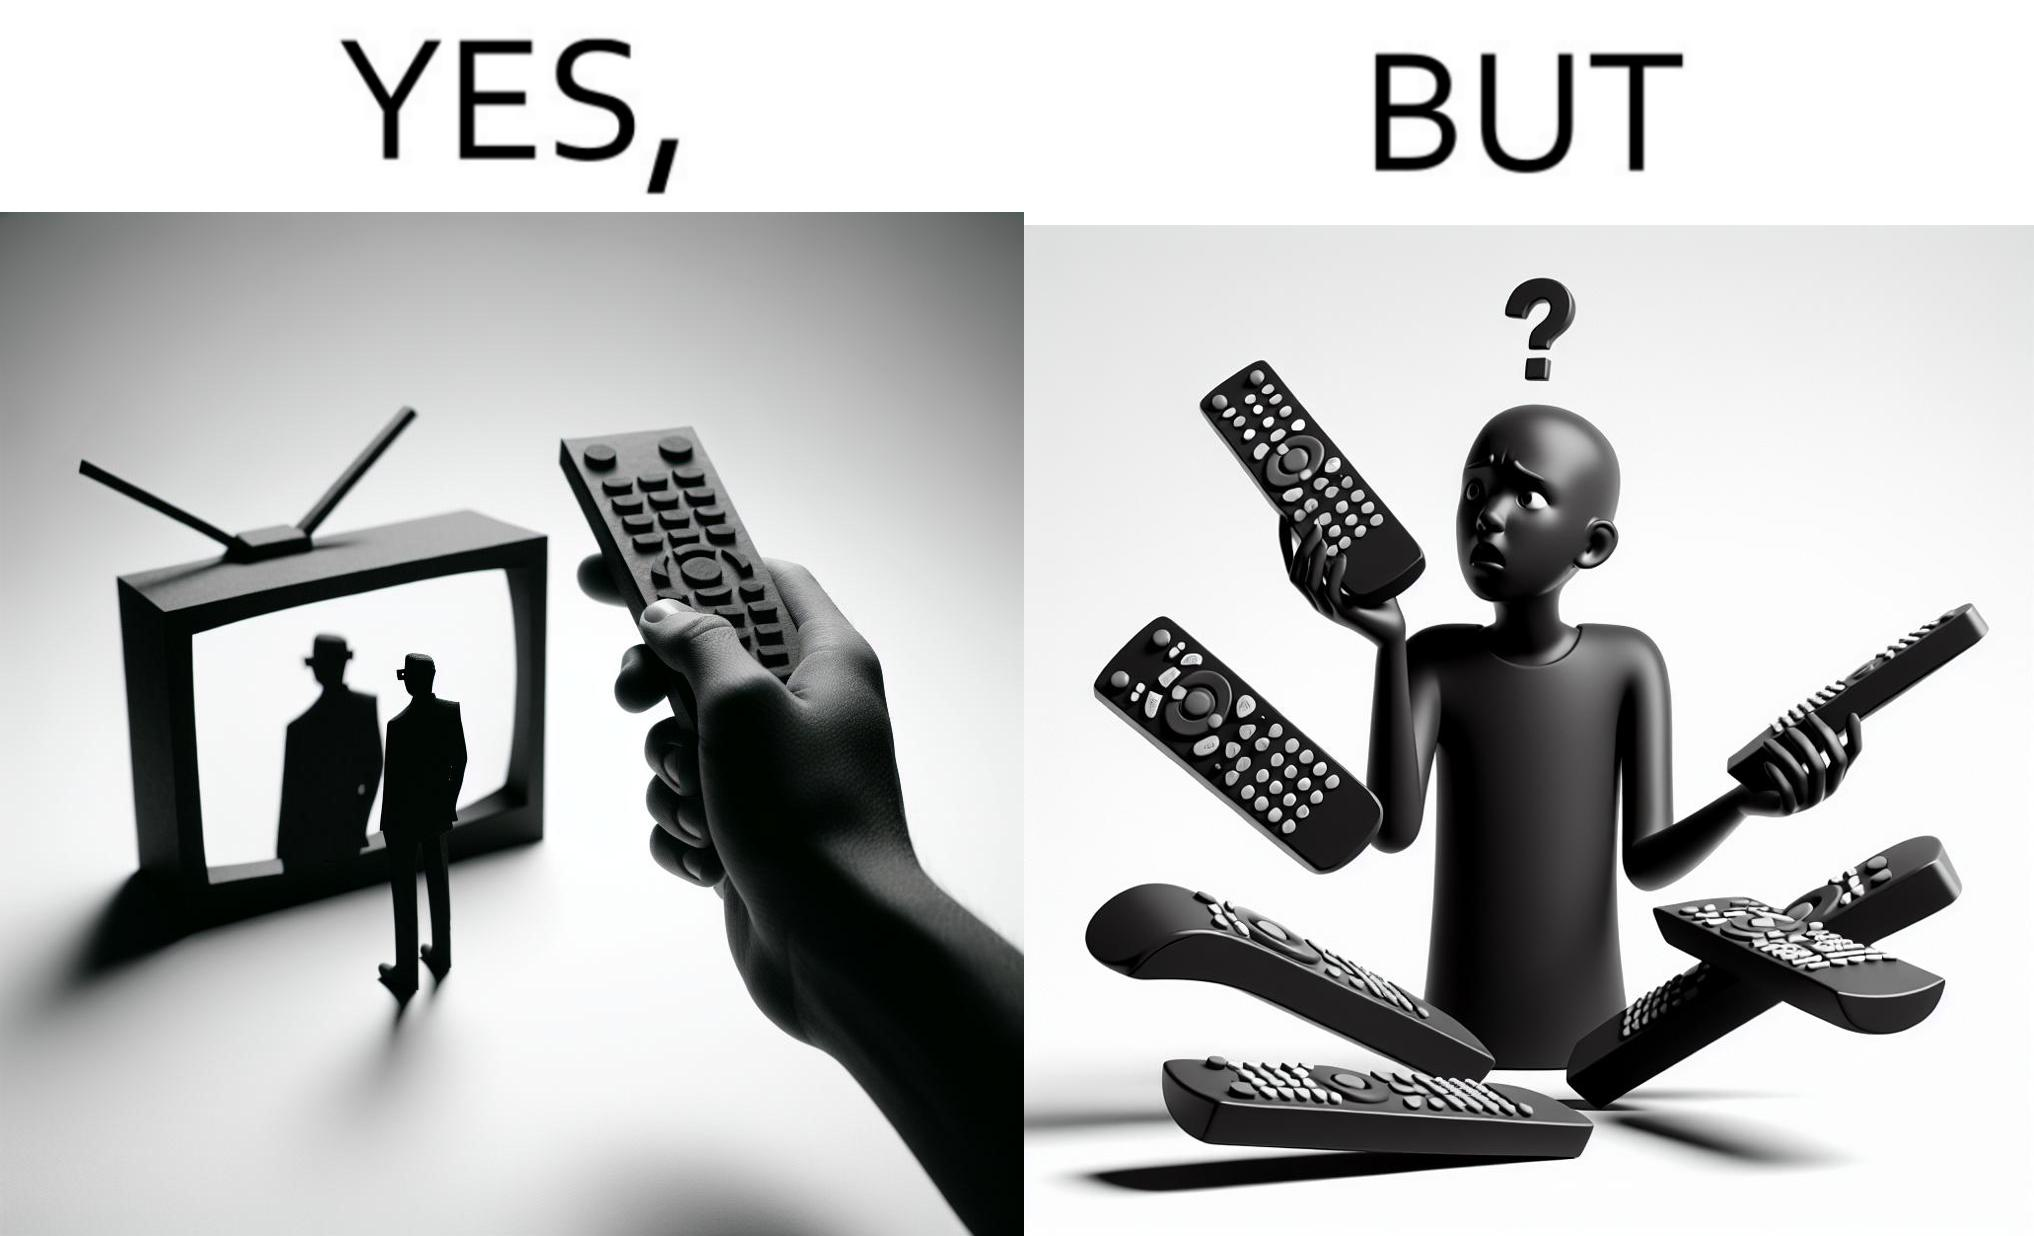What is the satirical meaning behind this image? The images are funny since they show how even though TV remotes are supposed to make operating TVs easier, having multiple similar looking remotes  for everything only makes it more difficult for the user to use the right one 